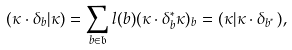<formula> <loc_0><loc_0><loc_500><loc_500>( \kappa \cdot \delta _ { b } | \kappa ) = \sum _ { b \in \mathfrak { b } } l ( b ) ( \kappa \cdot \delta _ { b } ^ { * } \kappa ) _ { b } = ( \kappa | \kappa \cdot \delta _ { b ^ { ^ { * } } } ) ,</formula> 